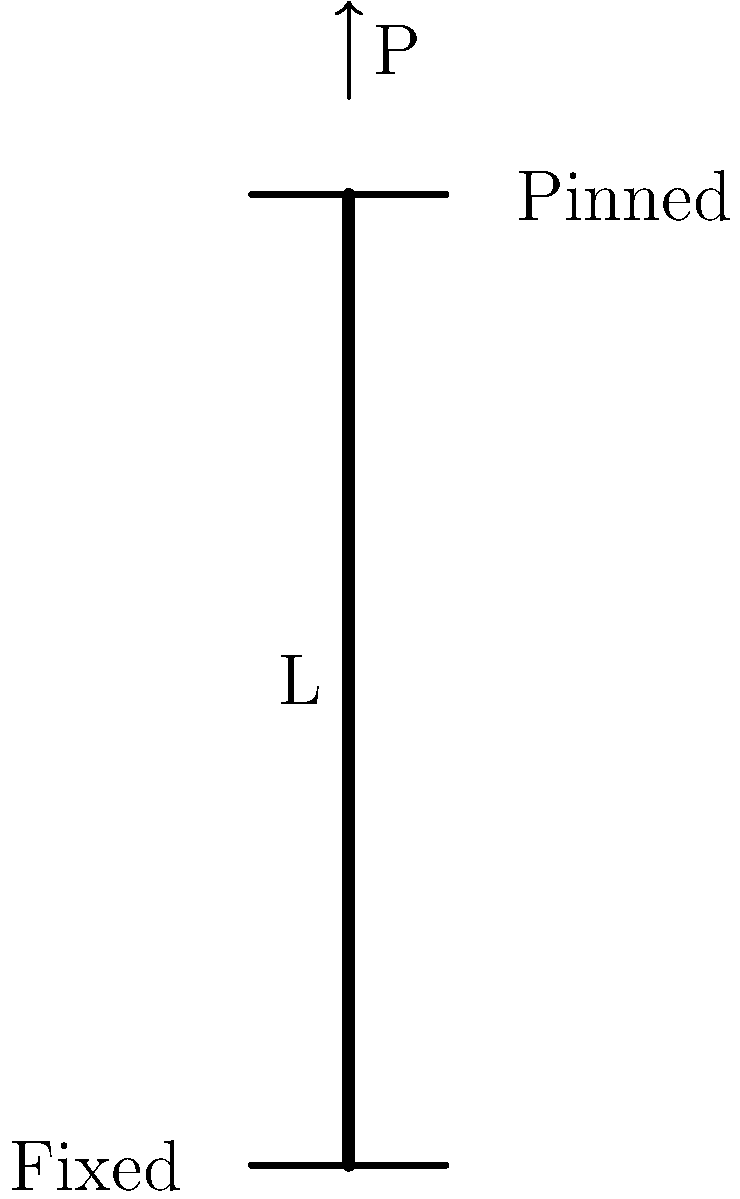Consider a column with a fixed base and a pinned top, as shown in the figure. The column has a length $L$, Young's modulus $E$, and moment of inertia $I$. What is the critical buckling load $P_{cr}$ for this column in terms of $E$, $I$, and $L$? To determine the critical buckling load for a column with different end conditions, we use Euler's formula with a modification factor based on the end conditions. The steps are as follows:

1. Recall Euler's formula for critical buckling load:
   $$P_{cr} = \frac{\pi^2 EI}{(KL)^2}$$
   where $K$ is the effective length factor.

2. For a column with one end fixed and one end pinned, the effective length factor $K = 0.699$.

3. Substitute this value into Euler's formula:
   $$P_{cr} = \frac{\pi^2 EI}{(0.699L)^2}$$

4. Simplify the equation:
   $$P_{cr} = \frac{\pi^2 EI}{0.488601L^2}$$

5. This can be further simplified to:
   $$P_{cr} = \frac{20.19 EI}{L^2}$$

Therefore, the critical buckling load for a column with a fixed base and a pinned top is approximately $\frac{20.19 EI}{L^2}$.
Answer: $P_{cr} = \frac{20.19 EI}{L^2}$ 